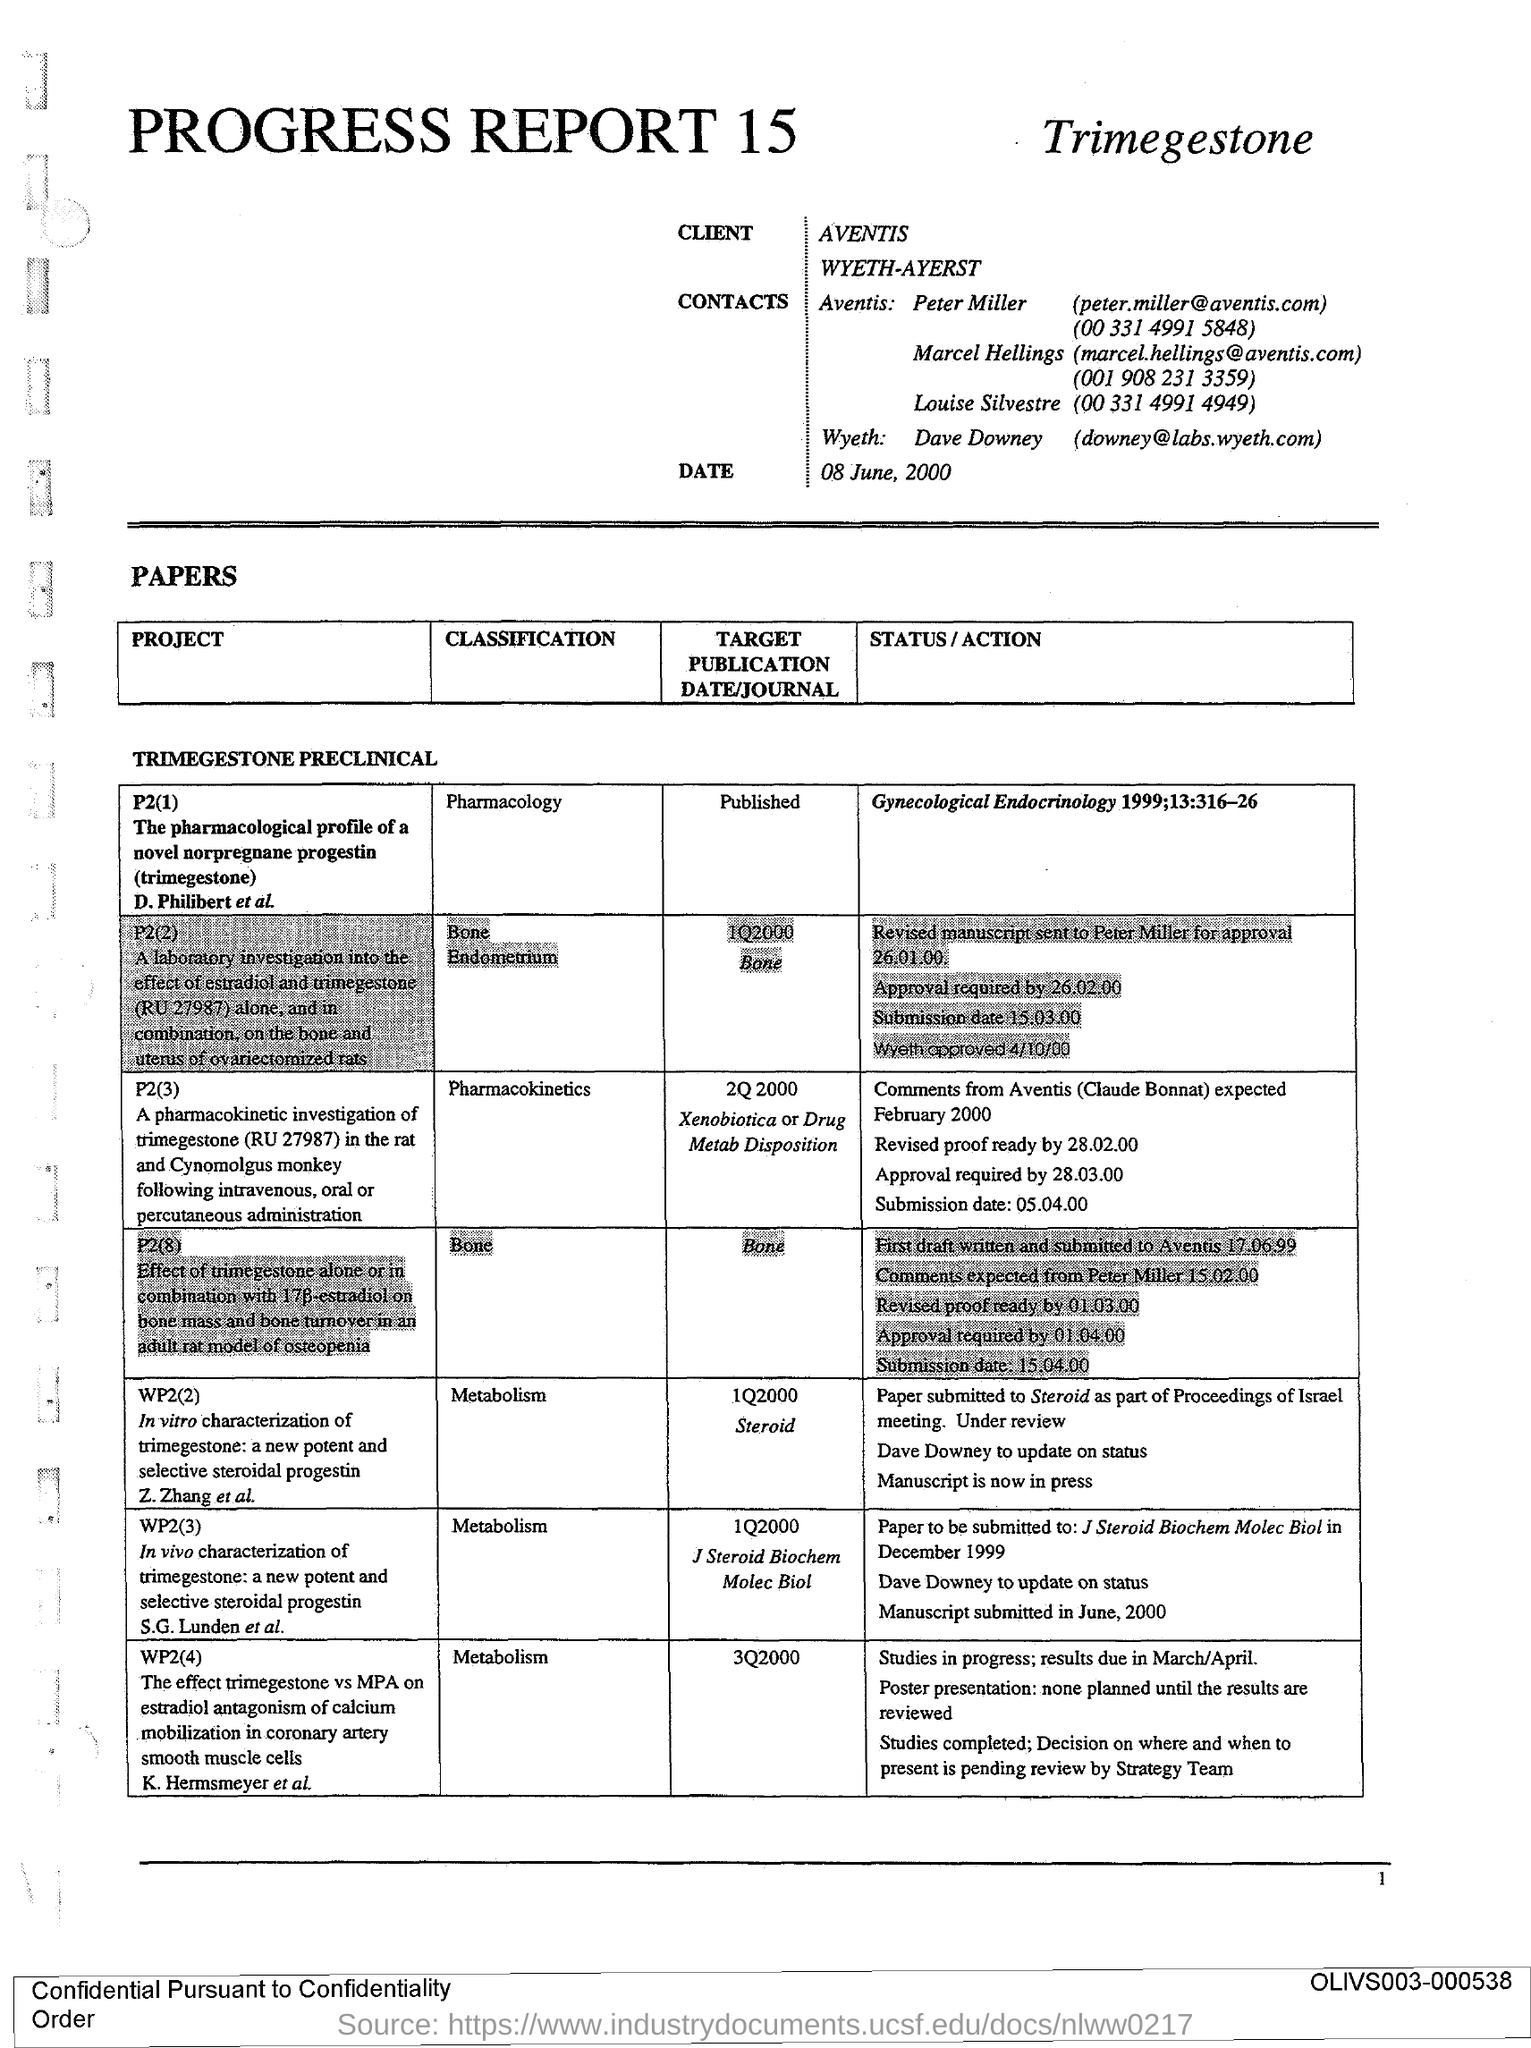Indicate a few pertinent items in this graphic. P2 (3) is classified as pharmacokinetics, which is the study of the dynamics of drug substances in the body over time. What is the target submission date/journal for project WP2(4)? The target submission date for project WP2(4) is 3Q2000. The telephone number of Louise Silvestre is 00 331 4991 4949. Peter Miller's email address is [peter.miller@aventis.com](mailto:peter.miller@aventis.com). The title of project WP2(2) is 'In vitro characterization of trimegestone: a new potent and selective steroidal progestin.' 